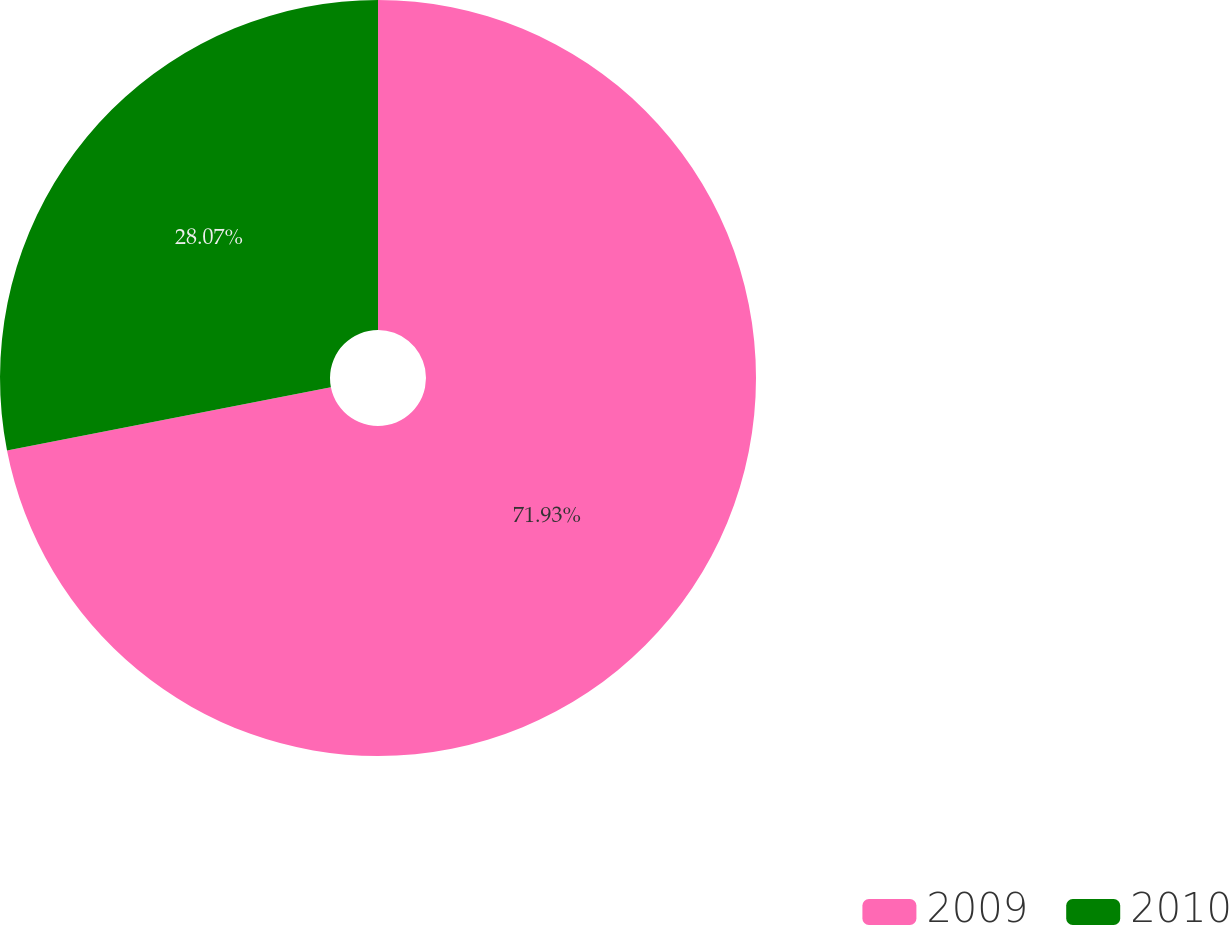Convert chart to OTSL. <chart><loc_0><loc_0><loc_500><loc_500><pie_chart><fcel>2009<fcel>2010<nl><fcel>71.93%<fcel>28.07%<nl></chart> 